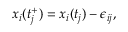<formula> <loc_0><loc_0><loc_500><loc_500>x _ { i } ( t _ { j } ^ { + } ) = x _ { i } ( t _ { j } ) - \epsilon _ { i j } ,</formula> 